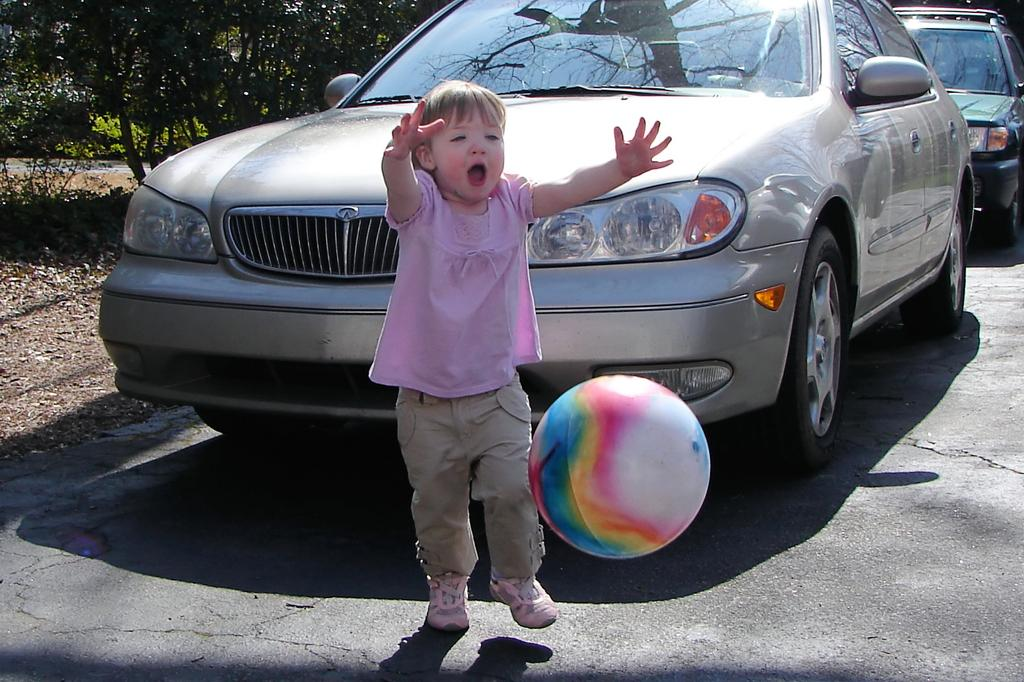What is the child doing in the image? The child is playing with a ball in the image. What can be seen on the road in the image? There are vehicles on the road in the image. What is visible in the background of the image? There are trees in the background of the image. What color is the tail of the silver vehicle in the image? There is no silver vehicle with a tail present in the image. The vehicles in the image are not described as being silver, and vehicles do not have tails. 